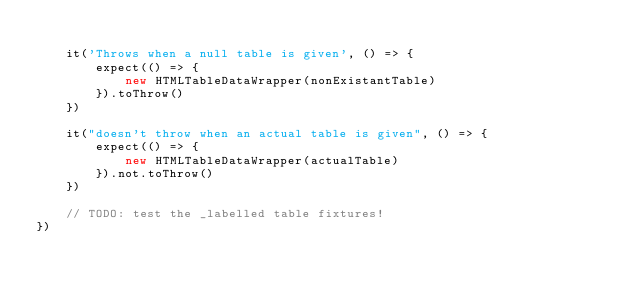<code> <loc_0><loc_0><loc_500><loc_500><_JavaScript_>
	it('Throws when a null table is given', () => {
		expect(() => {
			new HTMLTableDataWrapper(nonExistantTable)
		}).toThrow()
	})

	it("doesn't throw when an actual table is given", () => {
		expect(() => {
			new HTMLTableDataWrapper(actualTable)
		}).not.toThrow()
	})

	// TODO: test the _labelled table fixtures!
})
</code> 